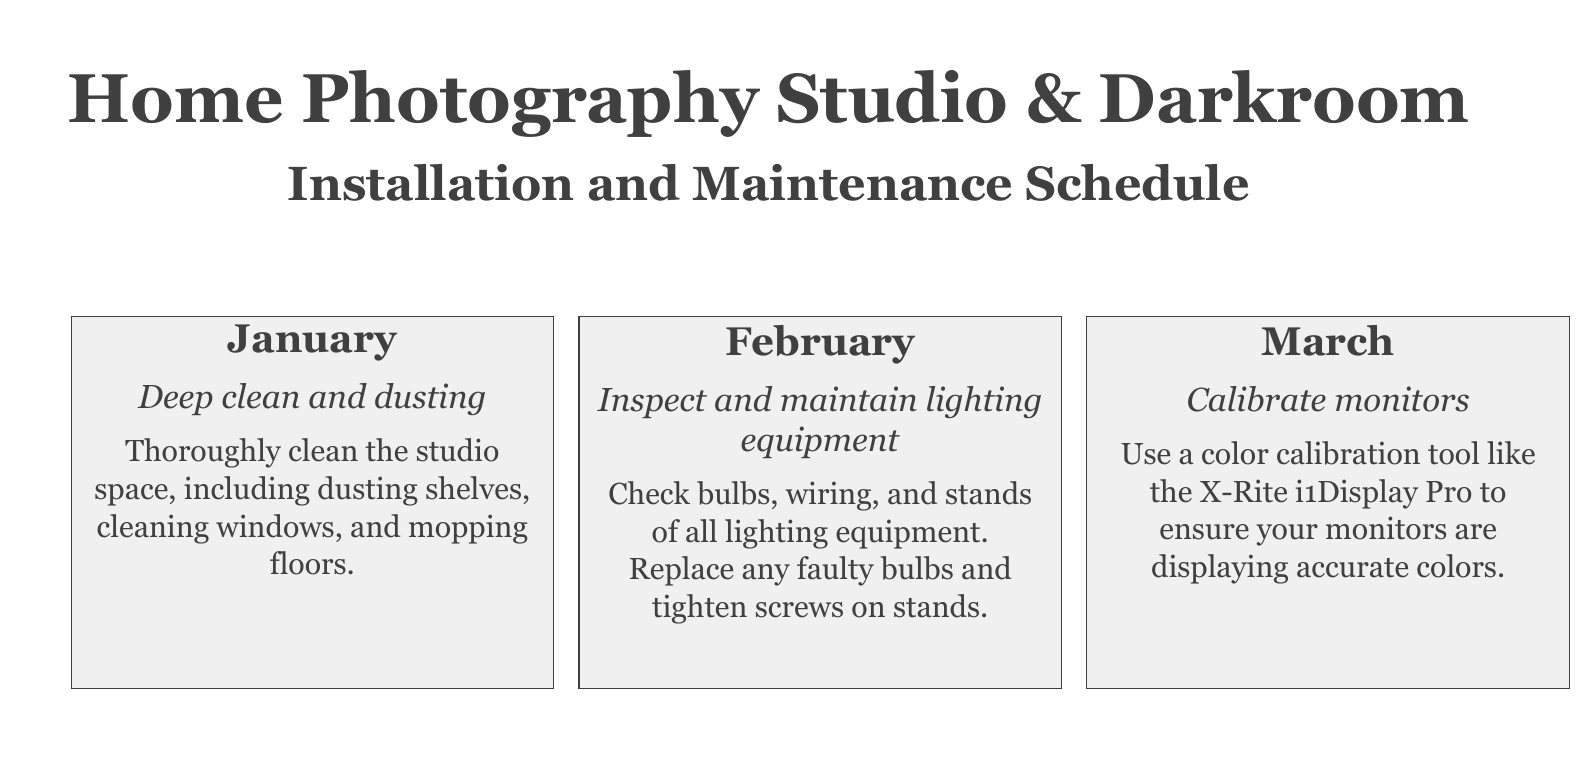What is the first maintenance task listed? The first maintenance task for January is deep cleaning and dusting the studio space.
Answer: Deep clean and dusting What month is designated for calibrating monitors? According to the schedule, March is the month for calibrating monitors.
Answer: March How often should the ventilation system be maintained? The document implies monthly maintenance tasks, indicating that every month has a different task, but June specifically focuses on ventilation.
Answer: June What type of equipment is to be inspected in February? The second month's task focuses on lighting equipment, including checking bulbs and wiring.
Answer: Lighting equipment Which month involves checking the chemical inventory? April is the month dedicated to checking the chemical inventory, verifying expiration dates.
Answer: April What action is to be taken in July regarding digital files? The task in July is to create backups of all digital files and images.
Answer: Backup digital files How many tasks are listed for the entire year? There are 12 specific maintenance tasks listed, one for each month of the year.
Answer: 12 What kind of maintenance occurs in September? September involves inspecting and cleaning the darkroom plumbing.
Answer: Darkroom plumbing check What is scheduled for December? The last task in December is an annual equipment audit.
Answer: Annual equipment audit 